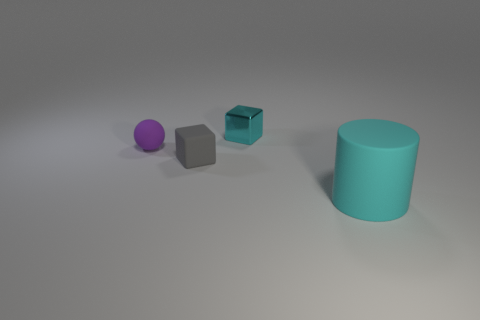Add 2 tiny balls. How many objects exist? 6 Subtract all spheres. How many objects are left? 3 Add 3 cyan metallic blocks. How many cyan metallic blocks are left? 4 Add 3 red metallic spheres. How many red metallic spheres exist? 3 Subtract 0 yellow cylinders. How many objects are left? 4 Subtract all tiny red shiny spheres. Subtract all small matte cubes. How many objects are left? 3 